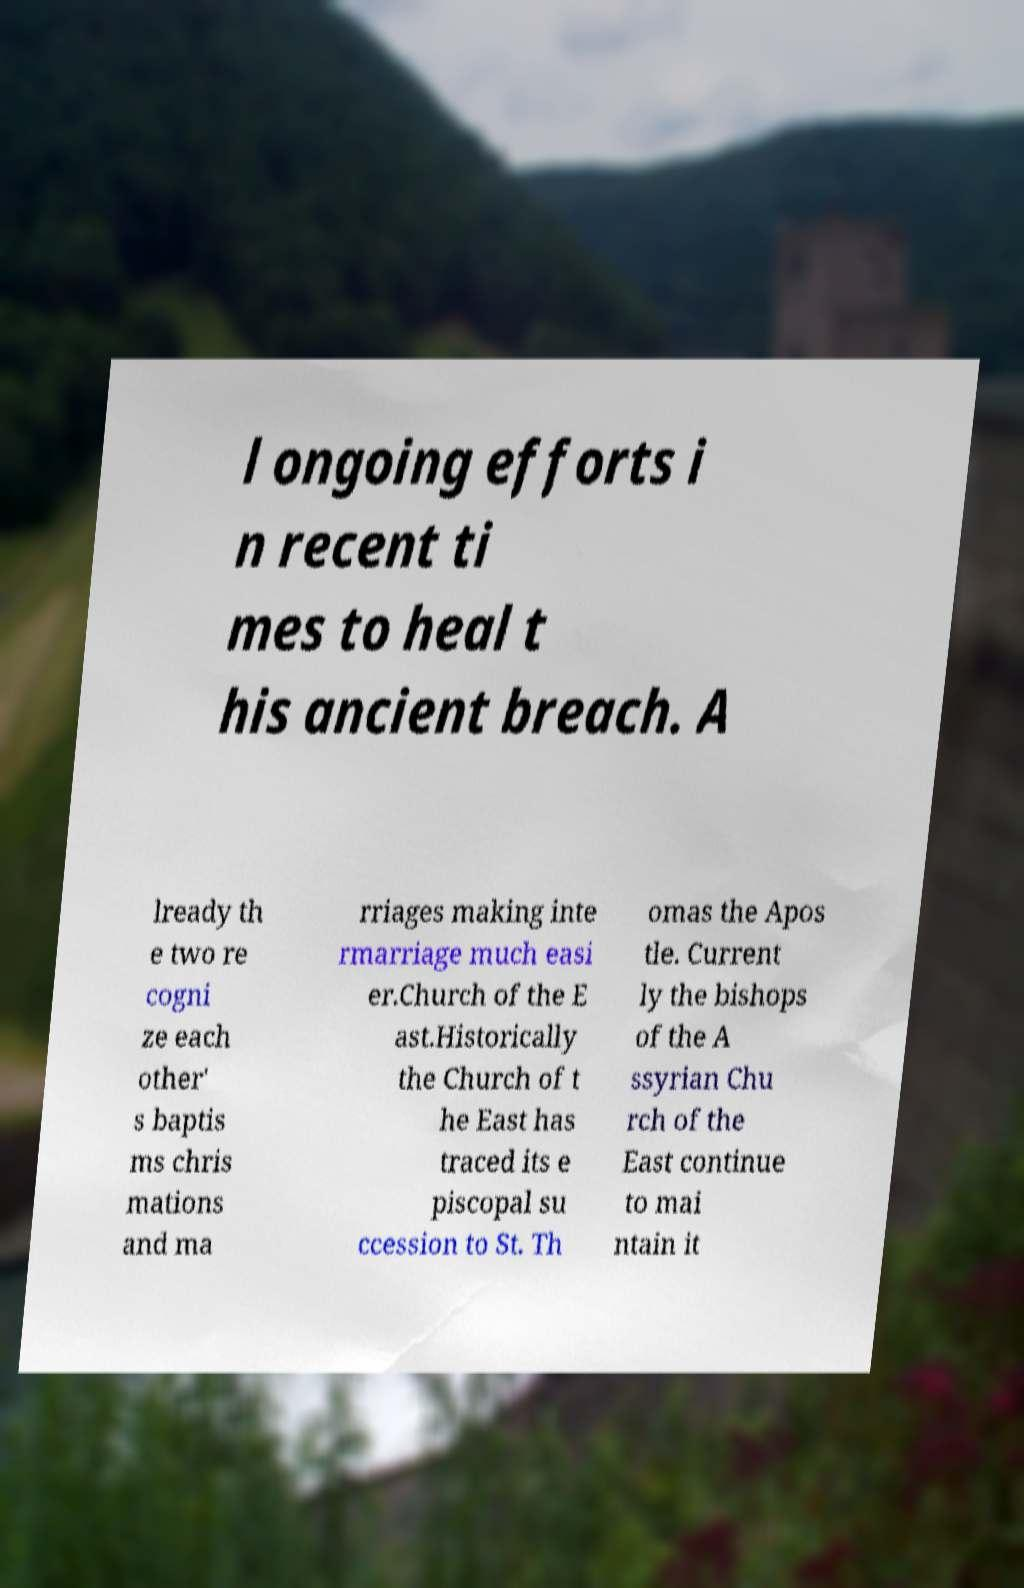For documentation purposes, I need the text within this image transcribed. Could you provide that? l ongoing efforts i n recent ti mes to heal t his ancient breach. A lready th e two re cogni ze each other' s baptis ms chris mations and ma rriages making inte rmarriage much easi er.Church of the E ast.Historically the Church of t he East has traced its e piscopal su ccession to St. Th omas the Apos tle. Current ly the bishops of the A ssyrian Chu rch of the East continue to mai ntain it 